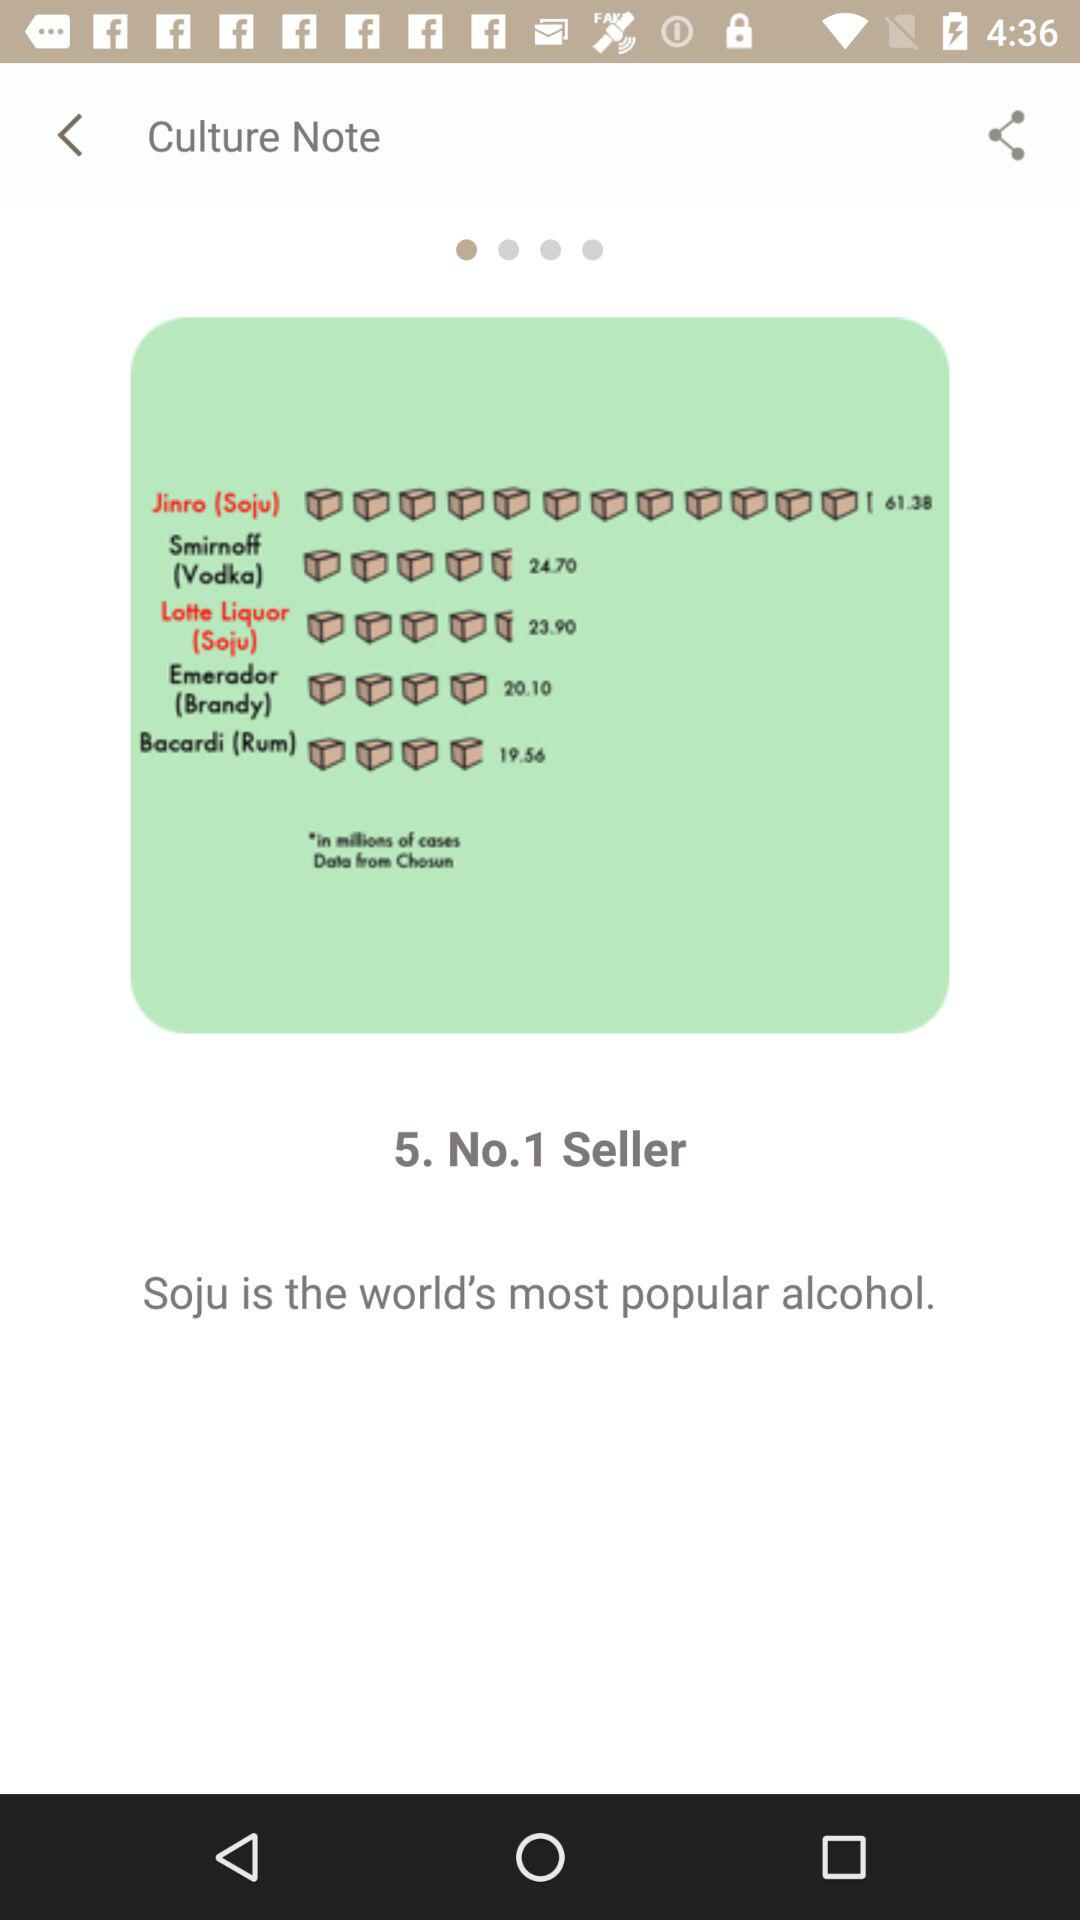What is the world's most popular alcohol? The world's most popular alcohol is soju. 